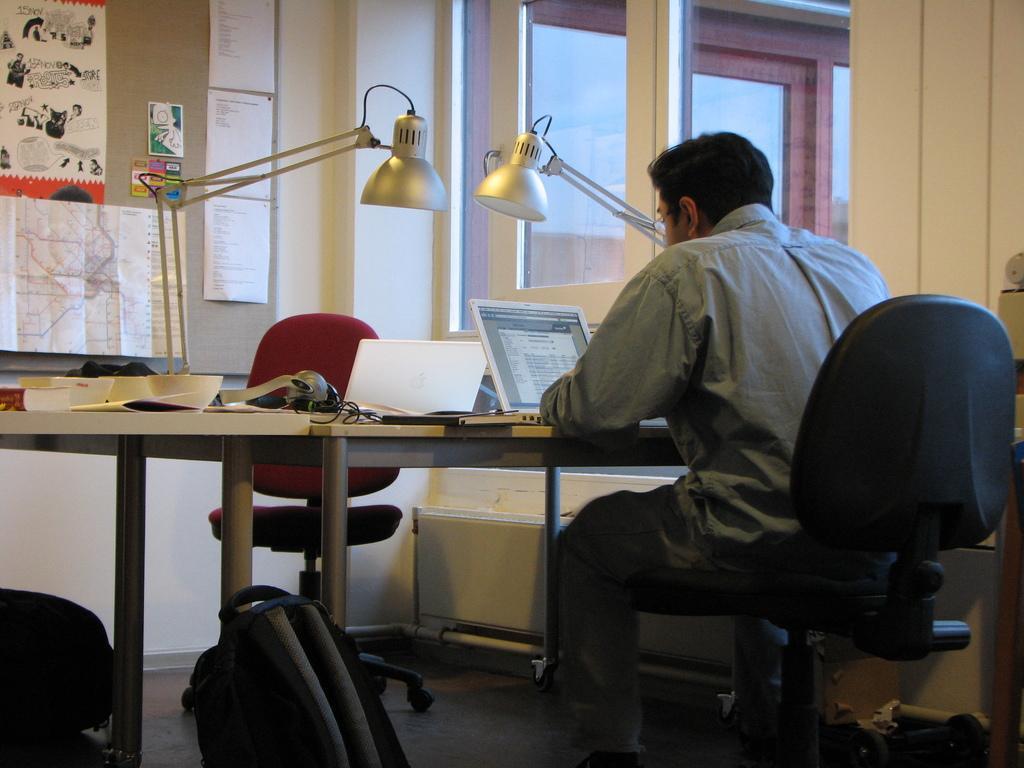Please provide a concise description of this image. In this image I can see a person wearing grey colored dress is sitting in a chair in front of a desk and on the desk I can see few laptops, few papers, two lights and few other objects. I can see a bag, a chair, the wall, a light and the window through which I can see the sky. 